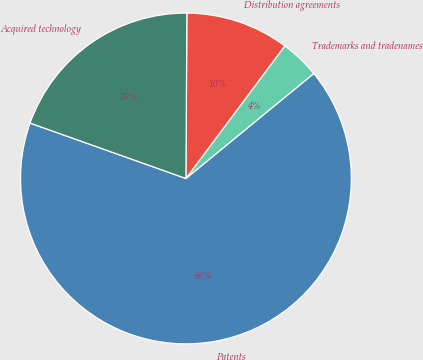Convert chart. <chart><loc_0><loc_0><loc_500><loc_500><pie_chart><fcel>Patents<fcel>Trademarks and tradenames<fcel>Distribution agreements<fcel>Acquired technology<nl><fcel>66.37%<fcel>3.86%<fcel>10.11%<fcel>19.65%<nl></chart> 